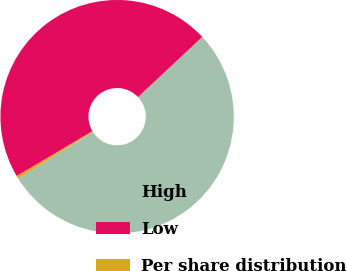<chart> <loc_0><loc_0><loc_500><loc_500><pie_chart><fcel>High<fcel>Low<fcel>Per share distribution<nl><fcel>53.09%<fcel>46.54%<fcel>0.37%<nl></chart> 